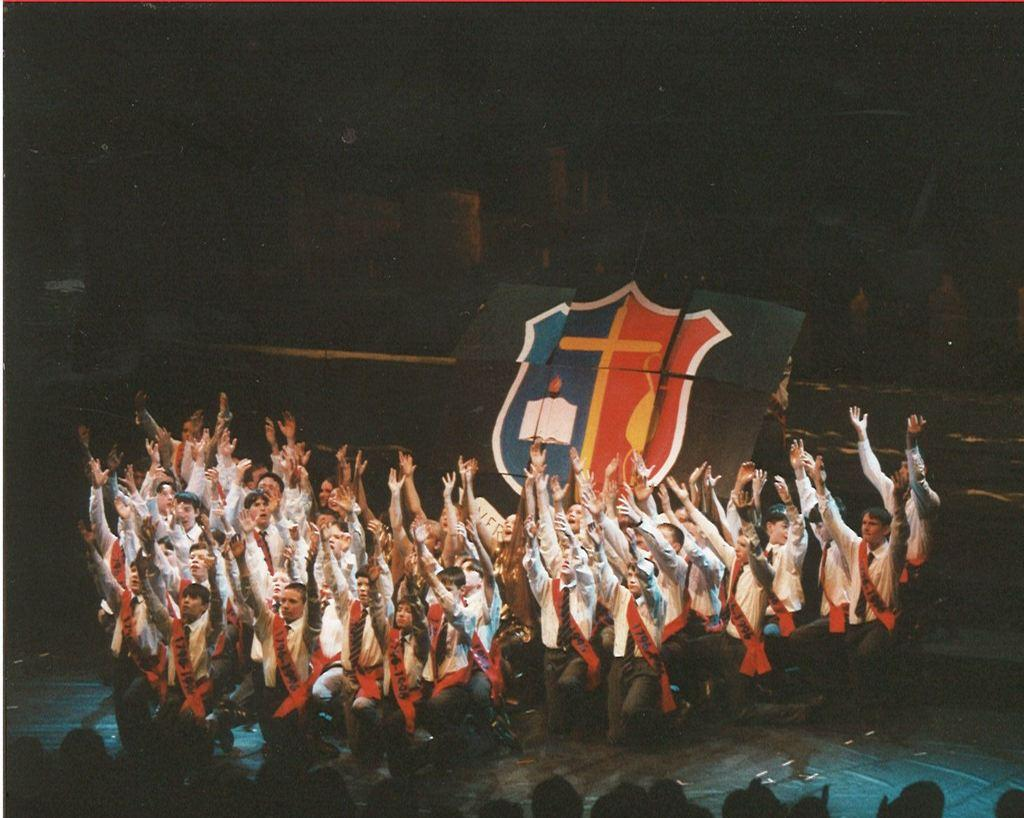What is happening on the stage in the image? There are many people on the stage, suggesting a performance or event. What can be seen in the background of the image? There is a logo in the background, which may indicate the event or organization associated with the stage. How would you describe the lighting in the image? The background is dark, which could suggest a nighttime event or a specific lighting setup for the stage. Are there any people in the front of the image? Yes, there are some people in the front, possibly in the audience or as part of the performance. What type of polish is being applied to the lettuce in the image? There is no lettuce or polish present in the image; it features a stage with people and a logo in the background. How many glasses are visible on the stage in the image? There are no glasses visible on the stage in the image. 